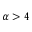<formula> <loc_0><loc_0><loc_500><loc_500>\alpha > 4</formula> 